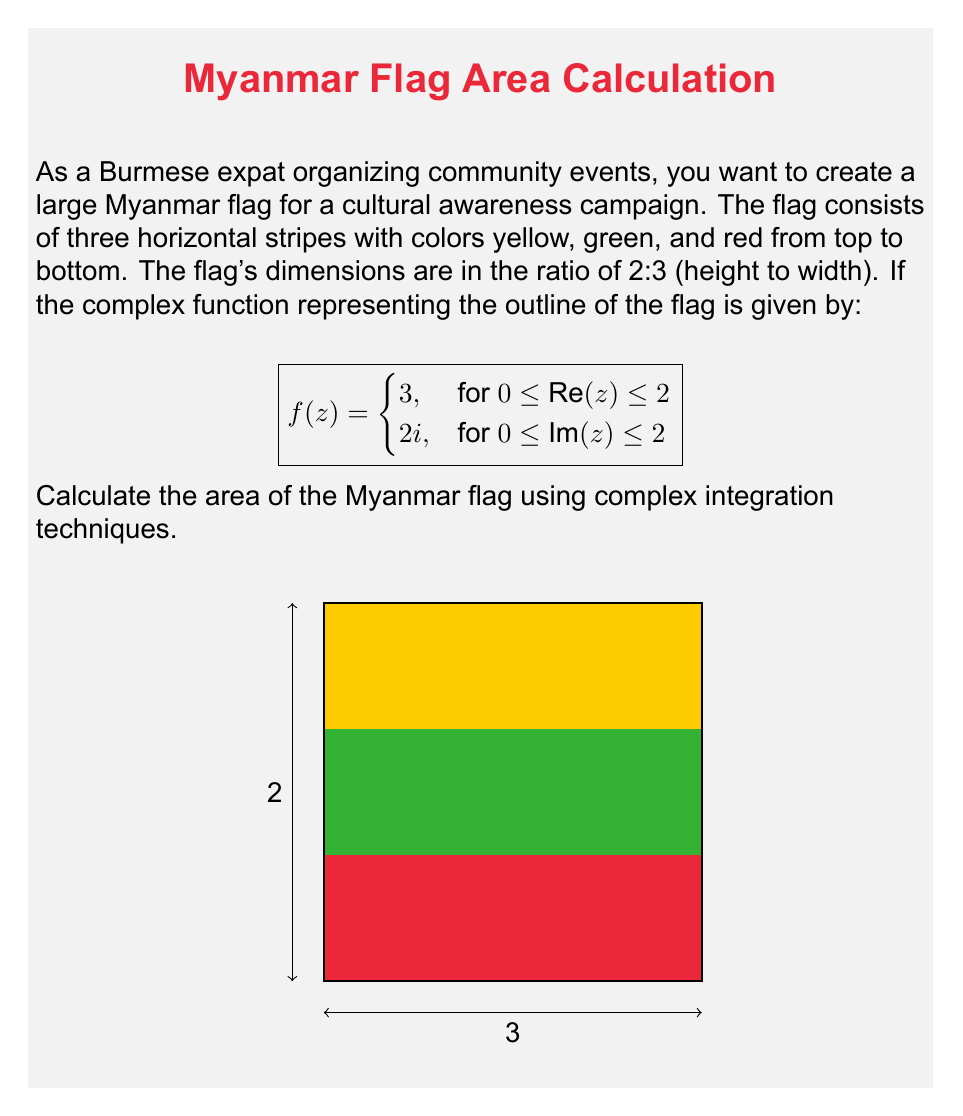Give your solution to this math problem. To calculate the area using complex integration, we'll use Green's theorem in the complex plane:

$$\text{Area} = \frac{1}{2i} \oint_C z \, dz$$

where $C$ is the positively oriented boundary of the flag.

Step 1: Parameterize the contour $C$
We'll split the contour into four parts:
- $C_1: z = t,\quad 0 \leq t \leq 2$
- $C_2: z = 2 + 2it,\quad 0 \leq t \leq 1$
- $C_3: z = (2-t) + 2i,\quad 0 \leq t \leq 2$
- $C_4: z = 2it,\quad 1 \geq t \geq 0$

Step 2: Calculate the integral along each part
For $C_1$: $\int_{C_1} z \, dz = \int_0^2 t \, dt = [t^2/2]_0^2 = 2$
For $C_2$: $\int_{C_2} z \, dz = \int_0^1 (2+2it)(2i \, dt) = 4i - 4$
For $C_3$: $\int_{C_3} z \, dz = \int_0^2 ((2-t)+2i)(-dt) = -4 - 4i$
For $C_4$: $\int_{C_4} z \, dz = \int_1^0 2it(-2i \, dt) = 2$

Step 3: Sum up the integrals
$$\oint_C z \, dz = 2 + (4i-4) + (-4-4i) + 2 = -4$$

Step 4: Apply the formula
$$\text{Area} = \frac{1}{2i} (-4) = 2$$

Therefore, the area of the flag is 2 square units.
Answer: 2 square units 